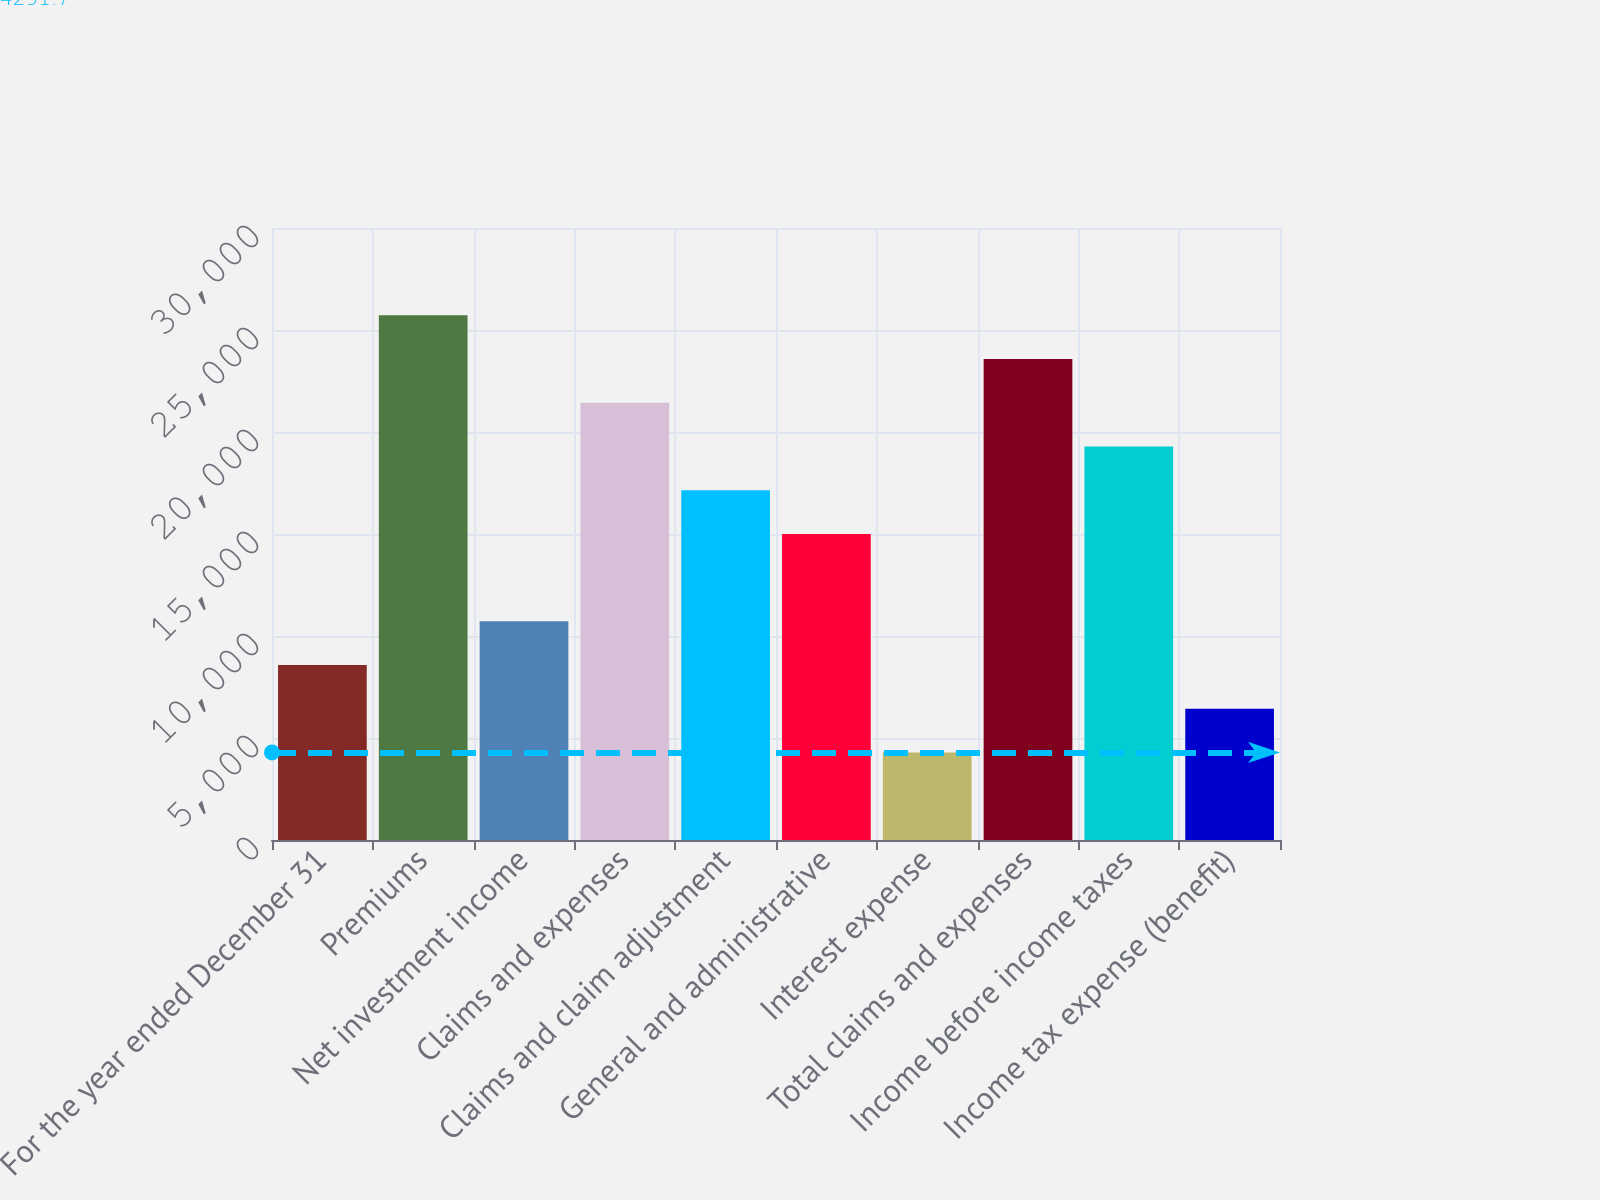Convert chart. <chart><loc_0><loc_0><loc_500><loc_500><bar_chart><fcel>For the year ended December 31<fcel>Premiums<fcel>Net investment income<fcel>Claims and expenses<fcel>Claims and claim adjustment<fcel>General and administrative<fcel>Interest expense<fcel>Total claims and expenses<fcel>Income before income taxes<fcel>Income tax expense (benefit)<nl><fcel>8576.78<fcel>25717.1<fcel>10719.3<fcel>21432<fcel>17146.9<fcel>15004.4<fcel>4291.7<fcel>23574.6<fcel>19289.5<fcel>6434.24<nl></chart> 